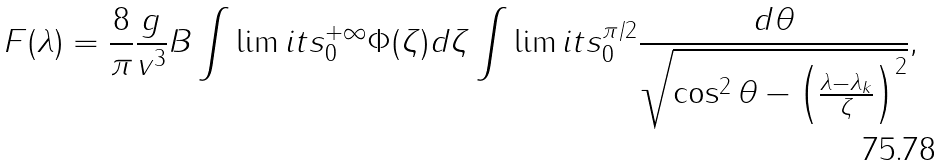<formula> <loc_0><loc_0><loc_500><loc_500>F ( \lambda ) = \frac { 8 } { \pi } \frac { g } { v ^ { 3 } } B \int \lim i t s _ { 0 } ^ { + \infty } \Phi ( \zeta ) d \zeta \int \lim i t s _ { 0 } ^ { \pi / 2 } \frac { d \theta } { \sqrt { \cos ^ { 2 } \theta - \left ( \frac { \lambda - \lambda _ { k } } { \zeta } \right ) ^ { 2 } } } ,</formula> 